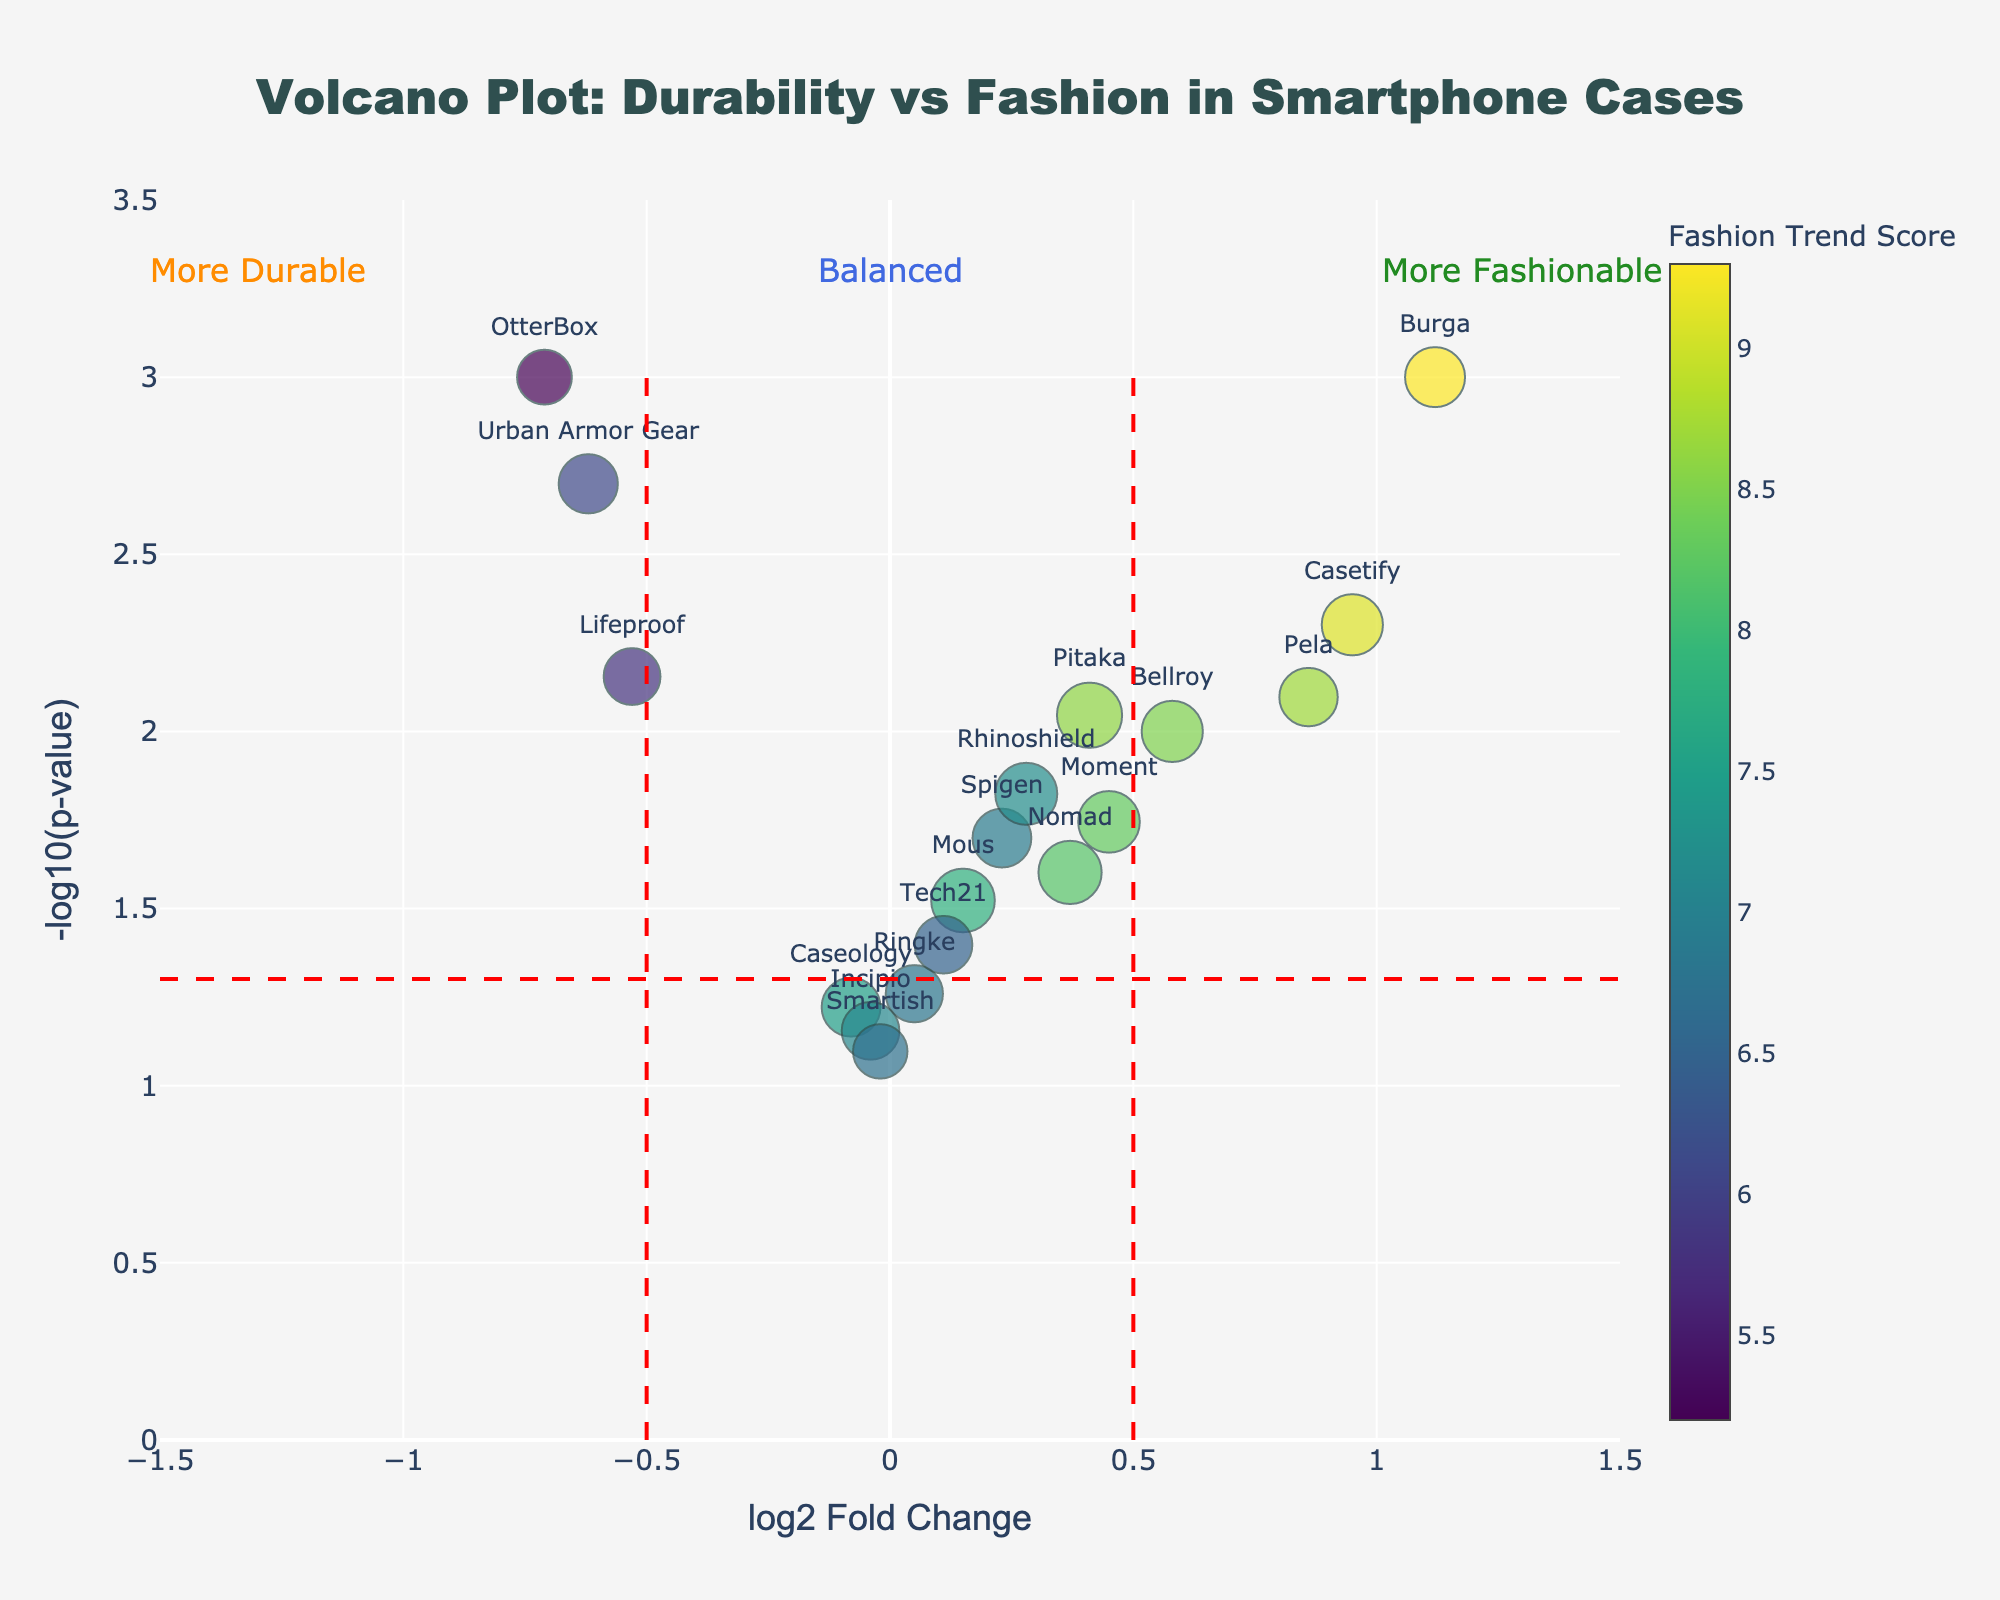What's the title of the plot? The title is displayed prominently at the top of the figure. It reads "Volcano Plot: Durability vs Fashion in Smartphone Cases."
Answer: Volcano Plot: Durability vs Fashion in Smartphone Cases How are the axes labeled? The x-axis is labeled as "log2 Fold Change," indicating the change in fashion trend versus durability, whereas the y-axis is labeled as "-log10(p-value)," indicating the significance of this change.
Answer: log2 Fold Change; -log10(p-value) How many smartphone case brands have a p-value less than 0.01? The threshold for a p-value of 0.01 corresponds to a y-value of 2 on the -log10 scale. Count the number of data points above this y-value.
Answer: 5 Which case brand is most fashionable? The case with the highest log2FoldChange value represents the most fashionable as per the y-axis. Burga has the highest log2FoldChange of 1.12.
Answer: Burga Which case brand has the best durability? The case with the most negative log2FoldChange represents the best durability as per the y-axis. OtterBox leads with the lowest value, -0.71.
Answer: OtterBox How many case brands fall into the "Balanced" region? The "Balanced" region is defined where log2FoldChange is between -0.5 and 0.5. Count the data points within this range.
Answer: 8 Which case brand is an outlier with extreme fashion preference but low durability? Identify the data point significantly high on log2FoldChange and relatively low on -log10(p-value). Burga stands out with the highest log2FoldChange and a -log10(p-value) of 3.
Answer: Burga Among OtterBox and Lifeproof, which brand is more significant in its trade-off between durability and fashion trend? Compare their y-values (-log10(p-value)). OtterBox has a value of 3, and Lifeproof has 2.15. OtterBox is more significant.
Answer: OtterBox Which case brand has a log2FoldChange near 0.5 and a relatively high significance? Find the point closest to 0.5 on the x-axis and yet above the significance threshold line at approximately y=1.3. Bellroy matches these criteria.
Answer: Bellroy 